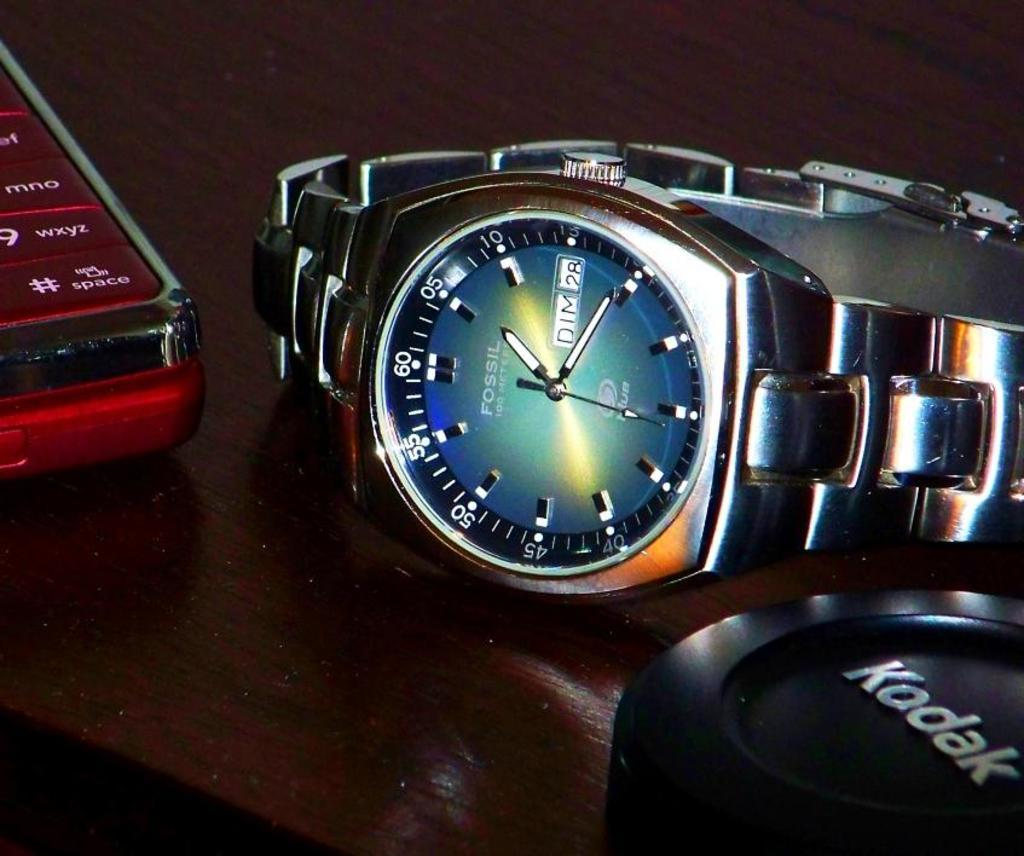<image>
Render a clear and concise summary of the photo. a Kodack camera lens sits on a table next to Fossil watch 